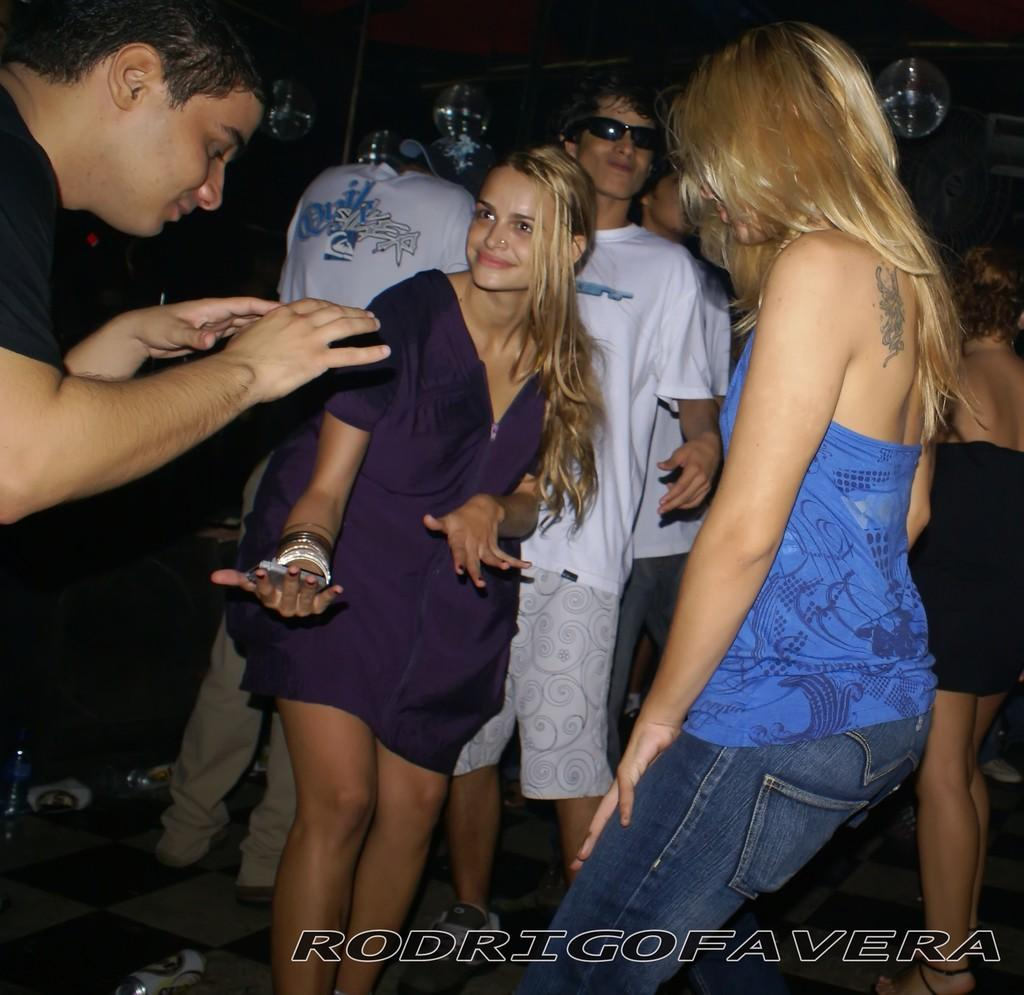What are the people in the image doing? The people in the image are dancing. Is there any text or marking at the bottom of the image? Yes, there is a watermark at the bottom of the image. Are the dogs in the image paying attention to the dancers? There are no dogs present in the image, so it is not possible to determine if they are paying attention to the dancers. 